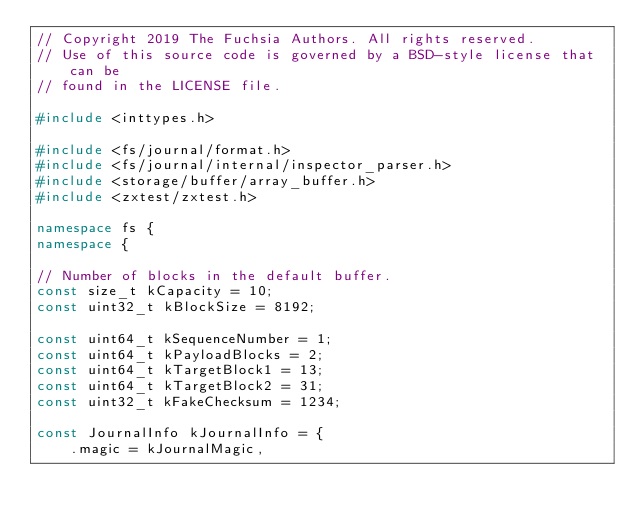Convert code to text. <code><loc_0><loc_0><loc_500><loc_500><_C++_>// Copyright 2019 The Fuchsia Authors. All rights reserved.
// Use of this source code is governed by a BSD-style license that can be
// found in the LICENSE file.

#include <inttypes.h>

#include <fs/journal/format.h>
#include <fs/journal/internal/inspector_parser.h>
#include <storage/buffer/array_buffer.h>
#include <zxtest/zxtest.h>

namespace fs {
namespace {

// Number of blocks in the default buffer.
const size_t kCapacity = 10;
const uint32_t kBlockSize = 8192;

const uint64_t kSequenceNumber = 1;
const uint64_t kPayloadBlocks = 2;
const uint64_t kTargetBlock1 = 13;
const uint64_t kTargetBlock2 = 31;
const uint32_t kFakeChecksum = 1234;

const JournalInfo kJournalInfo = {
    .magic = kJournalMagic,</code> 